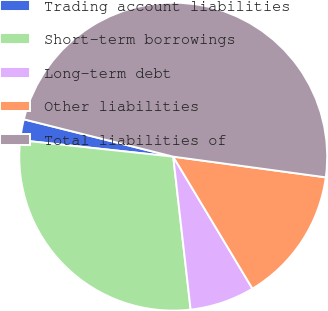Convert chart. <chart><loc_0><loc_0><loc_500><loc_500><pie_chart><fcel>Trading account liabilities<fcel>Short-term borrowings<fcel>Long-term debt<fcel>Other liabilities<fcel>Total liabilities of<nl><fcel>2.19%<fcel>28.51%<fcel>6.8%<fcel>14.25%<fcel>48.25%<nl></chart> 